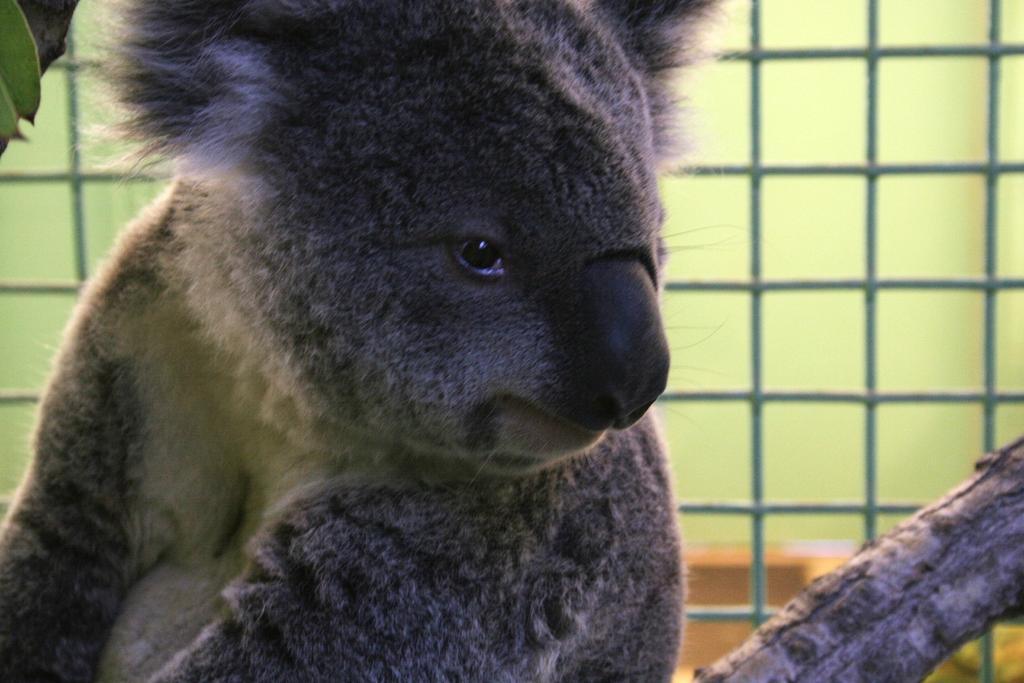In one or two sentences, can you explain what this image depicts? In this picture there is an animal. At the back there is a fence. On the right side of the image there is a tree branch. On the left side of the image there are two leaves on the tree branch. 